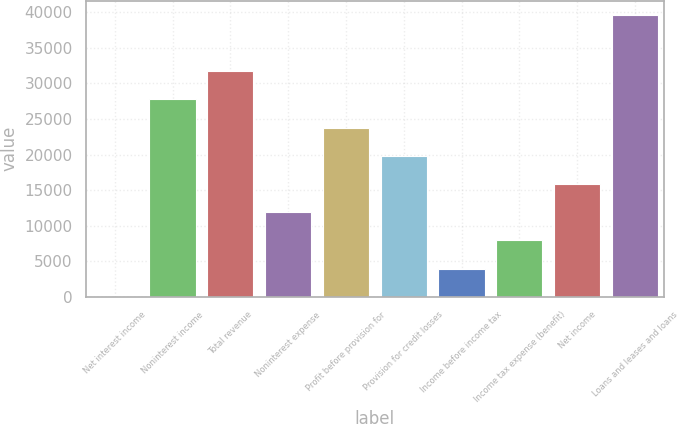<chart> <loc_0><loc_0><loc_500><loc_500><bar_chart><fcel>Net interest income<fcel>Noninterest income<fcel>Total revenue<fcel>Noninterest expense<fcel>Profit before provision for<fcel>Provision for credit losses<fcel>Income before income tax<fcel>Income tax expense (benefit)<fcel>Net income<fcel>Loans and leases and loans<nl><fcel>27<fcel>27753.3<fcel>31714.2<fcel>11909.7<fcel>23792.4<fcel>19831.5<fcel>3987.9<fcel>7948.8<fcel>15870.6<fcel>39636<nl></chart> 